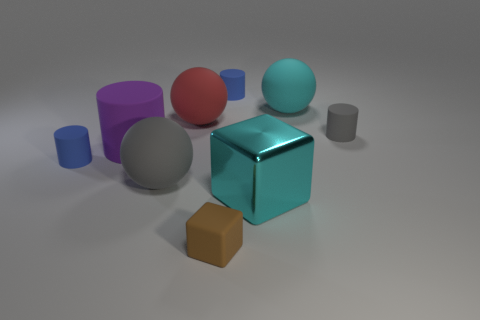Is there any other thing that is the same size as the cyan metal object?
Make the answer very short. Yes. What number of things are things that are left of the tiny gray rubber cylinder or gray rubber things that are on the right side of the cyan rubber thing?
Give a very brief answer. 9. There is a cyan metallic thing; what shape is it?
Keep it short and to the point. Cube. How many other objects are the same material as the purple object?
Give a very brief answer. 7. There is a matte object that is the same shape as the shiny thing; what size is it?
Provide a short and direct response. Small. What is the material of the large thing that is to the left of the gray thing that is on the left side of the gray rubber thing that is behind the large purple rubber object?
Your answer should be compact. Rubber. Is there a gray metal cube?
Offer a very short reply. No. There is a metallic cube; is it the same color as the large sphere on the right side of the cyan metal thing?
Your answer should be very brief. Yes. The large rubber cylinder has what color?
Your response must be concise. Purple. The tiny thing that is the same shape as the large metal thing is what color?
Offer a very short reply. Brown. 